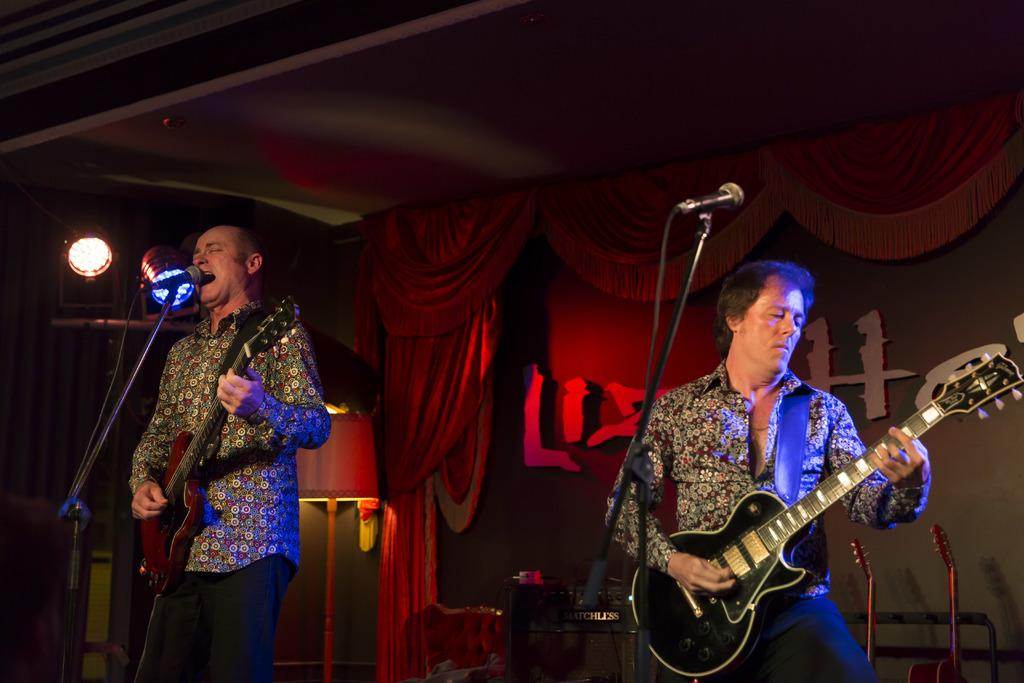How many people are in the image? There are two men in the image. What are the men doing in the image? The men are standing in front of a microphone. What instruments are the men holding? Both men are holding a guitar. What can be seen in the background of the image? There are lights and a curtain in the background of the image. How many ants can be seen crawling on the chairs in the image? There are no chairs or ants present in the image. What type of instrument is the man playing in the image? The image does not show the men playing any instruments; they are only holding guitars. 